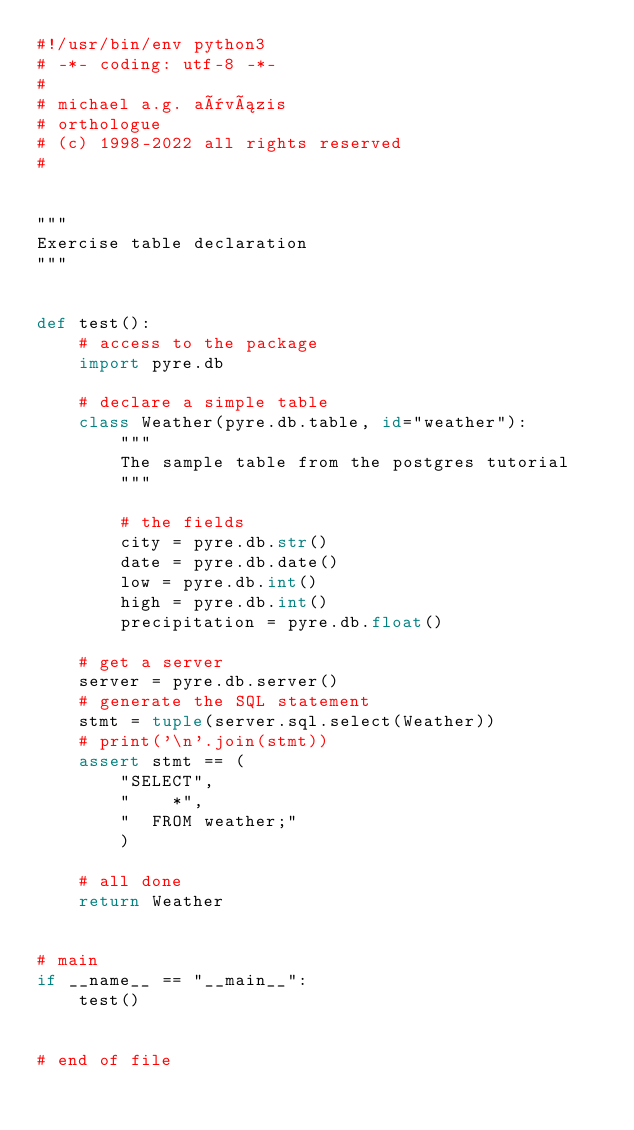<code> <loc_0><loc_0><loc_500><loc_500><_Python_>#!/usr/bin/env python3
# -*- coding: utf-8 -*-
#
# michael a.g. aïvázis
# orthologue
# (c) 1998-2022 all rights reserved
#


"""
Exercise table declaration
"""


def test():
    # access to the package
    import pyre.db

    # declare a simple table
    class Weather(pyre.db.table, id="weather"):
        """
        The sample table from the postgres tutorial
        """

        # the fields
        city = pyre.db.str()
        date = pyre.db.date()
        low = pyre.db.int()
        high = pyre.db.int()
        precipitation = pyre.db.float()

    # get a server
    server = pyre.db.server()
    # generate the SQL statement
    stmt = tuple(server.sql.select(Weather))
    # print('\n'.join(stmt))
    assert stmt == (
        "SELECT",
        "    *",
        "  FROM weather;"
        )

    # all done
    return Weather


# main
if __name__ == "__main__":
    test()


# end of file
</code> 